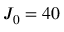<formula> <loc_0><loc_0><loc_500><loc_500>{ { J } _ { 0 } } = 4 0</formula> 